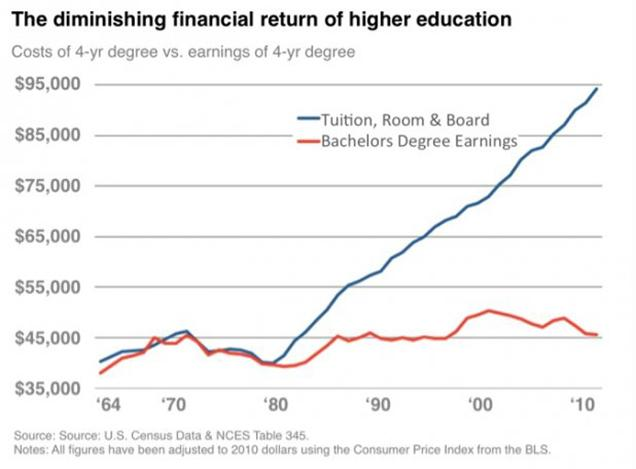Specify some key components in this picture. According to the graph, the cost of tuition, room and board has increased up to $95,000. The red line on the graph represents the Bachelors Degree Earnings, which is a parameter that can be observed visually. The cost of a four-year degree, including tuition, room, and board, falls under the category of educational expenses. The representation of Tuition, Room & Board on the graph is shown in blue. 